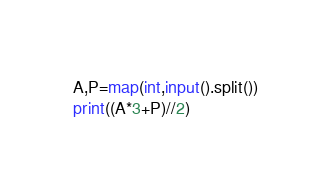Convert code to text. <code><loc_0><loc_0><loc_500><loc_500><_Python_>A,P=map(int,input().split())
print((A*3+P)//2)</code> 